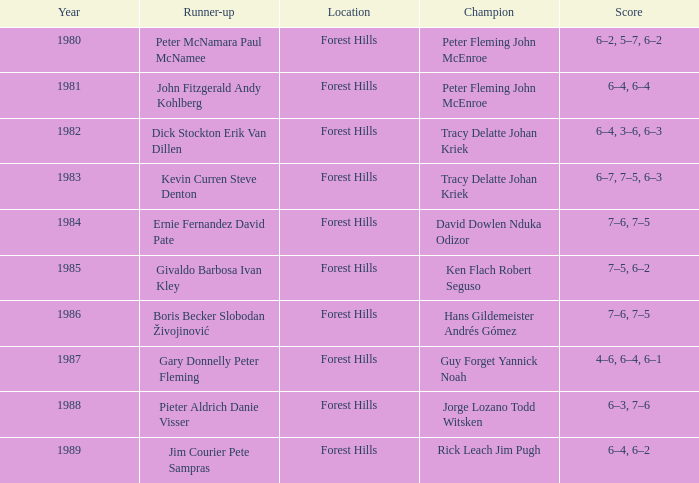Who was the runner-up in 1989? Jim Courier Pete Sampras. 